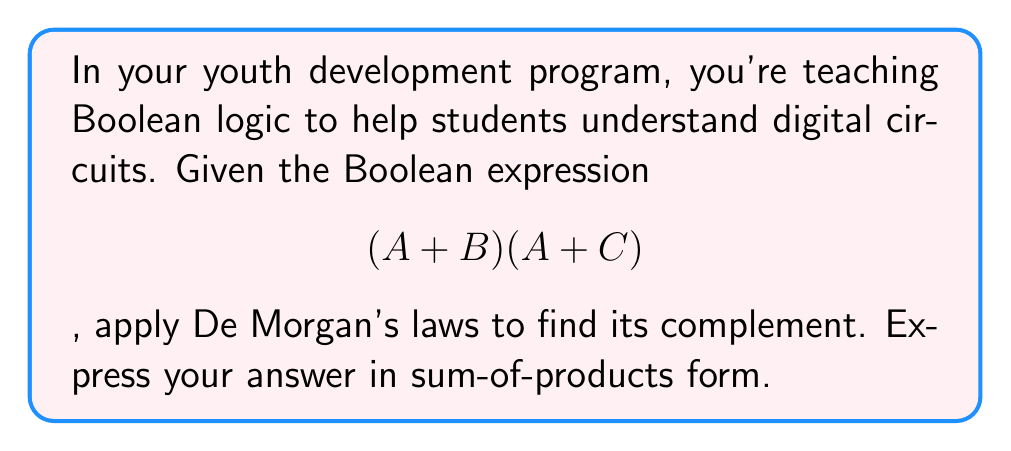Teach me how to tackle this problem. Let's approach this step-by-step:

1) First, we need to find the complement of the given expression. Let's call the original expression X:

   $$X = (A + B)(A + C)$$

2) To find the complement, we'll use the notation $\overline{X}$:

   $$\overline{X} = \overline{(A + B)(A + C)}$$

3) Now we can apply De Morgan's first law. This law states that the complement of a product is equal to the sum of the complements:

   $$\overline{X} = \overline{(A + B)} + \overline{(A + C)}$$

4) Next, we apply De Morgan's second law to each term. This law states that the complement of a sum is equal to the product of the complements:

   $$\overline{X} = (\overline{A} \cdot \overline{B}) + (\overline{A} \cdot \overline{C})$$

5) This expression is already in sum-of-products form, so we're done!
Answer: $$(\overline{A} \cdot \overline{B}) + (\overline{A} \cdot \overline{C})$$ 